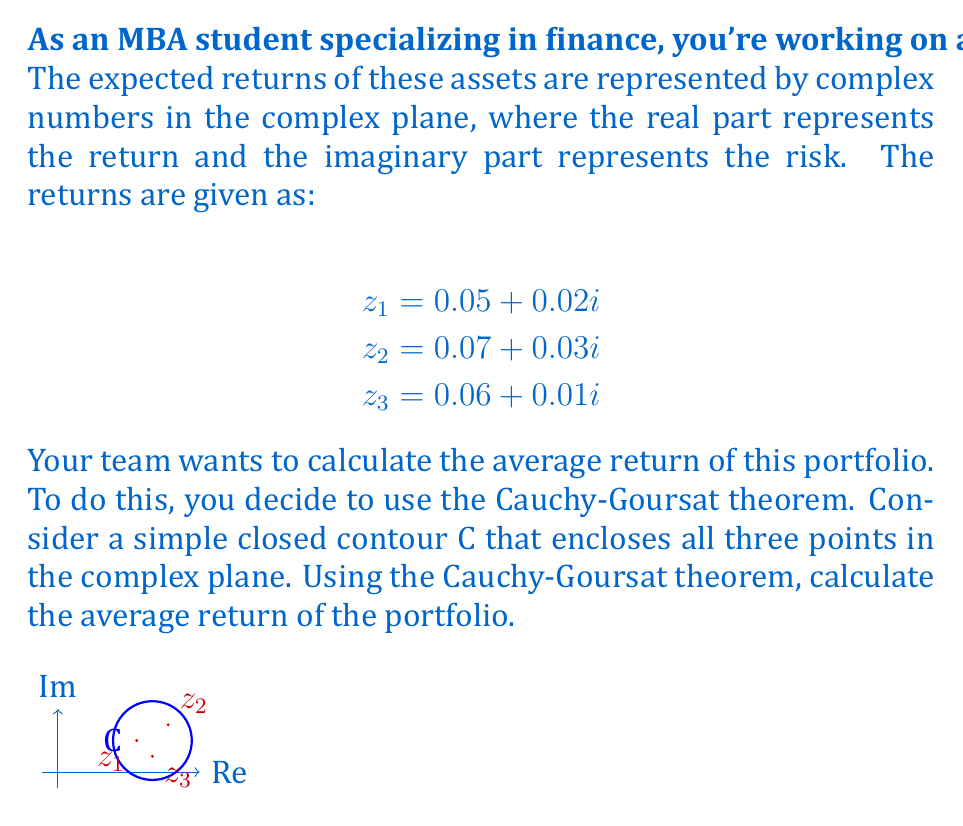Can you solve this math problem? Let's approach this step-by-step:

1) The Cauchy-Goursat theorem states that for an analytic function $f(z)$ inside and on a simple closed contour C:

   $$\oint_C f(z) dz = 0$$

2) We can use this to find the average of our points. Let's define a function:

   $$f(z) = \frac{1}{z-z_1} + \frac{1}{z-z_2} + \frac{1}{z-z_3}$$

3) The residue of $f(z)$ at each point $z_k$ is 1. The sum of residues inside C is 3.

4) By the residue theorem:

   $$\oint_C f(z) dz = 2\pi i \sum \text{Res}(f,z_k) = 2\pi i \cdot 3 = 6\pi i$$

5) Now, let's consider the function:

   $$g(z) = z \cdot f(z) = \frac{z}{z-z_1} + \frac{z}{z-z_2} + \frac{z}{z-z_3}$$

6) The residue of $g(z)$ at each point $z_k$ is $z_k$. Therefore:

   $$\oint_C g(z) dz = 2\pi i (z_1 + z_2 + z_3)$$

7) Dividing this by the result from step 4:

   $$\frac{\oint_C g(z) dz}{\oint_C f(z) dz} = \frac{2\pi i (z_1 + z_2 + z_3)}{6\pi i} = \frac{z_1 + z_2 + z_3}{3}$$

8) This gives us the average of the three points:

   $$\frac{(0.05 + 0.02i) + (0.07 + 0.03i) + (0.06 + 0.01i)}{3} = \frac{0.18 + 0.06i}{3} = 0.06 + 0.02i$$

Therefore, the average return of the portfolio is 0.06 (6%) with an average risk of 0.02 (2%).
Answer: $0.06 + 0.02i$ 